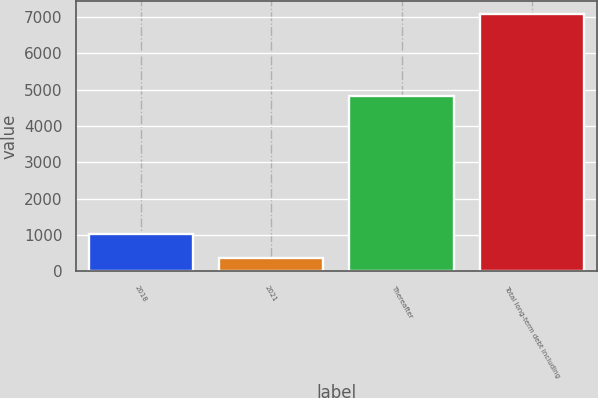Convert chart. <chart><loc_0><loc_0><loc_500><loc_500><bar_chart><fcel>2018<fcel>2021<fcel>Thereafter<fcel>Total long-term debt including<nl><fcel>1043.4<fcel>371<fcel>4824<fcel>7095<nl></chart> 